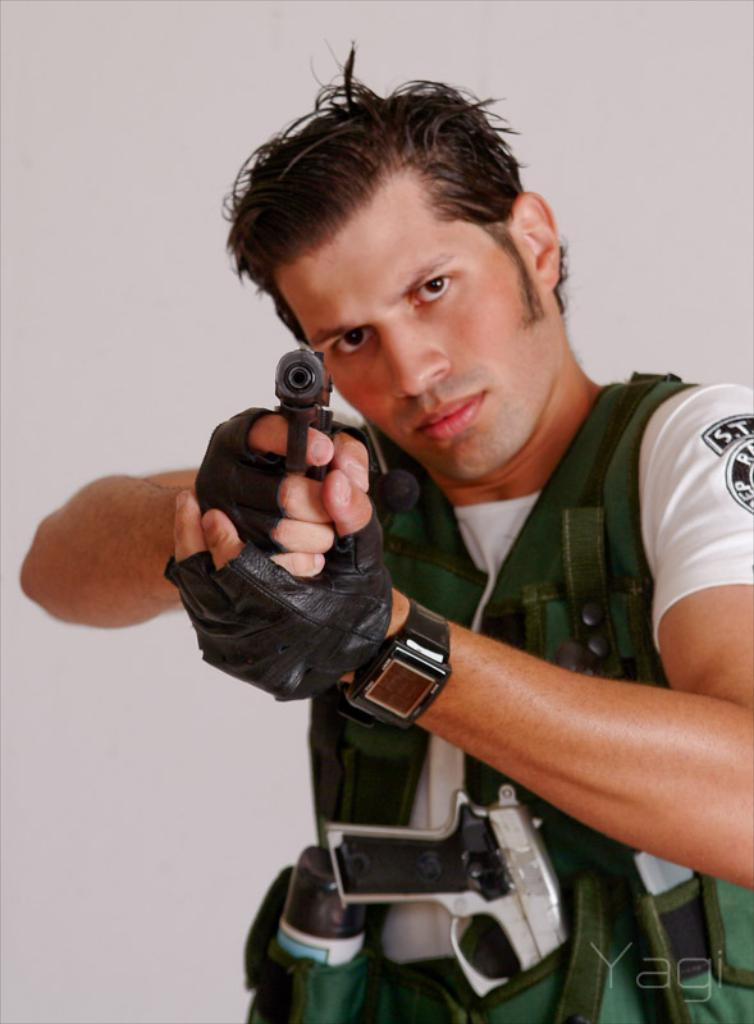What is the main subject of the image? There is a person in the image. What is the person holding in the image? The person is holding a gun. What is the color of the background in the image? The background of the image is white. What type of bird can be seen flying in the image? There is no bird present in the image. What type of approval is the person seeking in the image? There is no indication in the image that the person is seeking any approval. What type of airplane can be seen in the image? There is no airplane present in the image. 